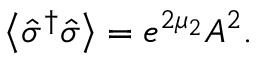<formula> <loc_0><loc_0><loc_500><loc_500>\left \langle \hat { \sigma } ^ { \dagger } \hat { \sigma } \right \rangle = e ^ { 2 \mu _ { 2 } } A ^ { 2 } .</formula> 